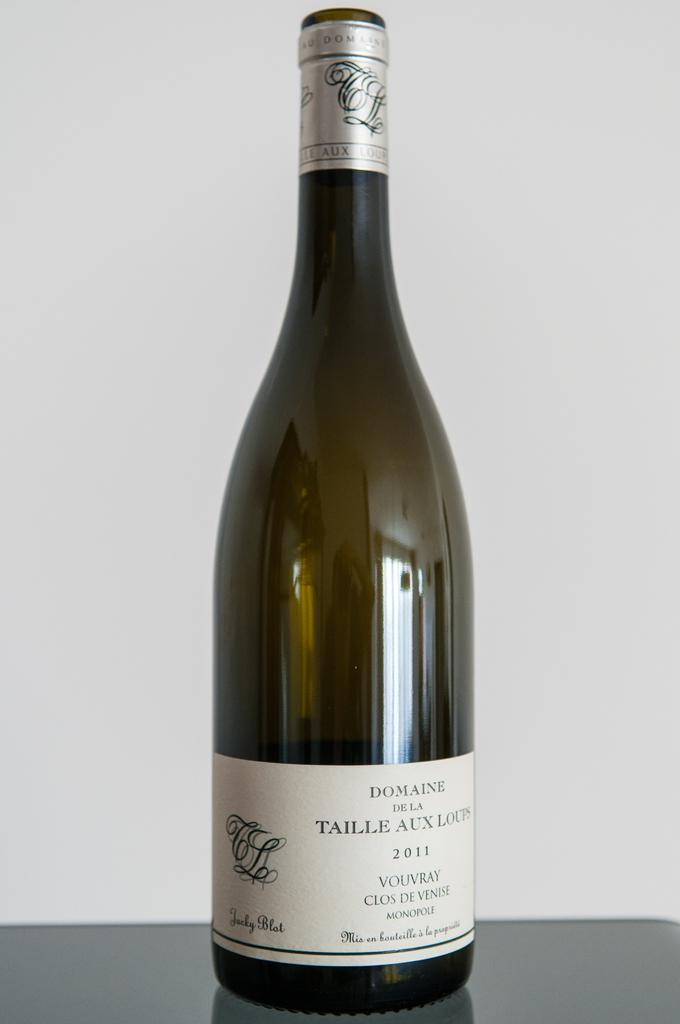<image>
Write a terse but informative summary of the picture. A bottle of wine from 2011 has fancy script on the label. 